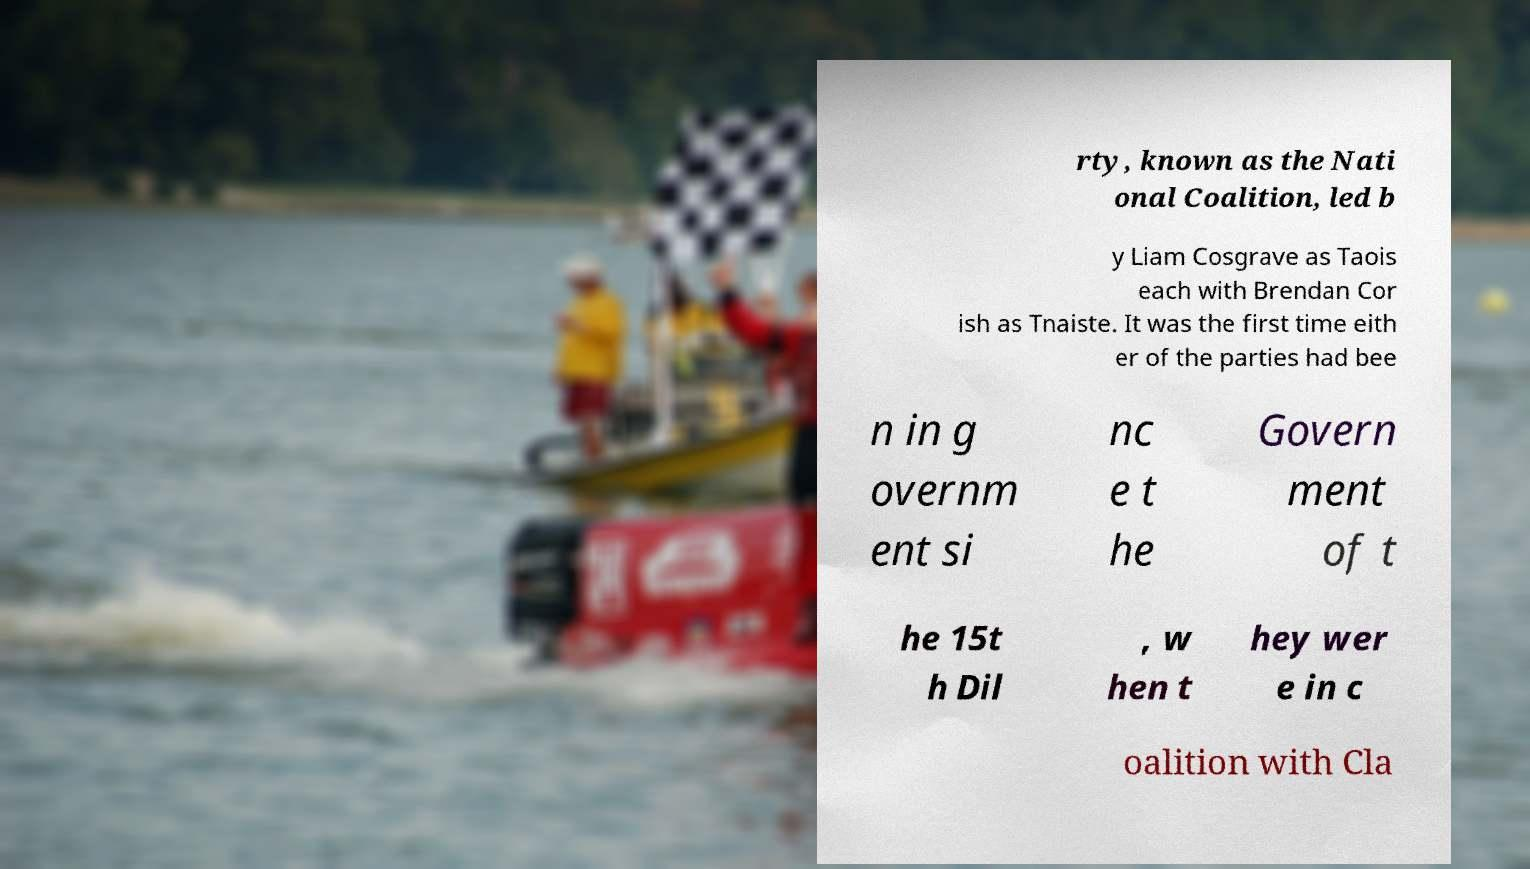Please read and relay the text visible in this image. What does it say? rty, known as the Nati onal Coalition, led b y Liam Cosgrave as Taois each with Brendan Cor ish as Tnaiste. It was the first time eith er of the parties had bee n in g overnm ent si nc e t he Govern ment of t he 15t h Dil , w hen t hey wer e in c oalition with Cla 